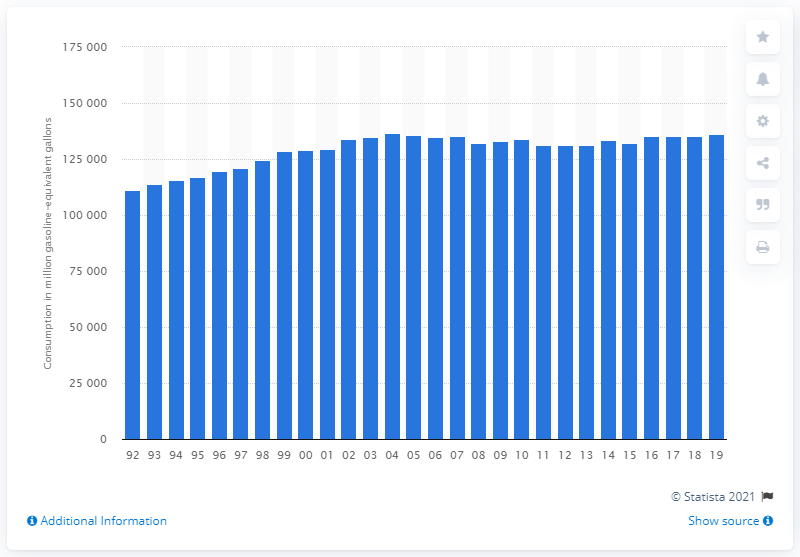List a handful of essential elements in this visual. In 2019, the amount of gasoline consumed by motor vehicles was 136,078. 